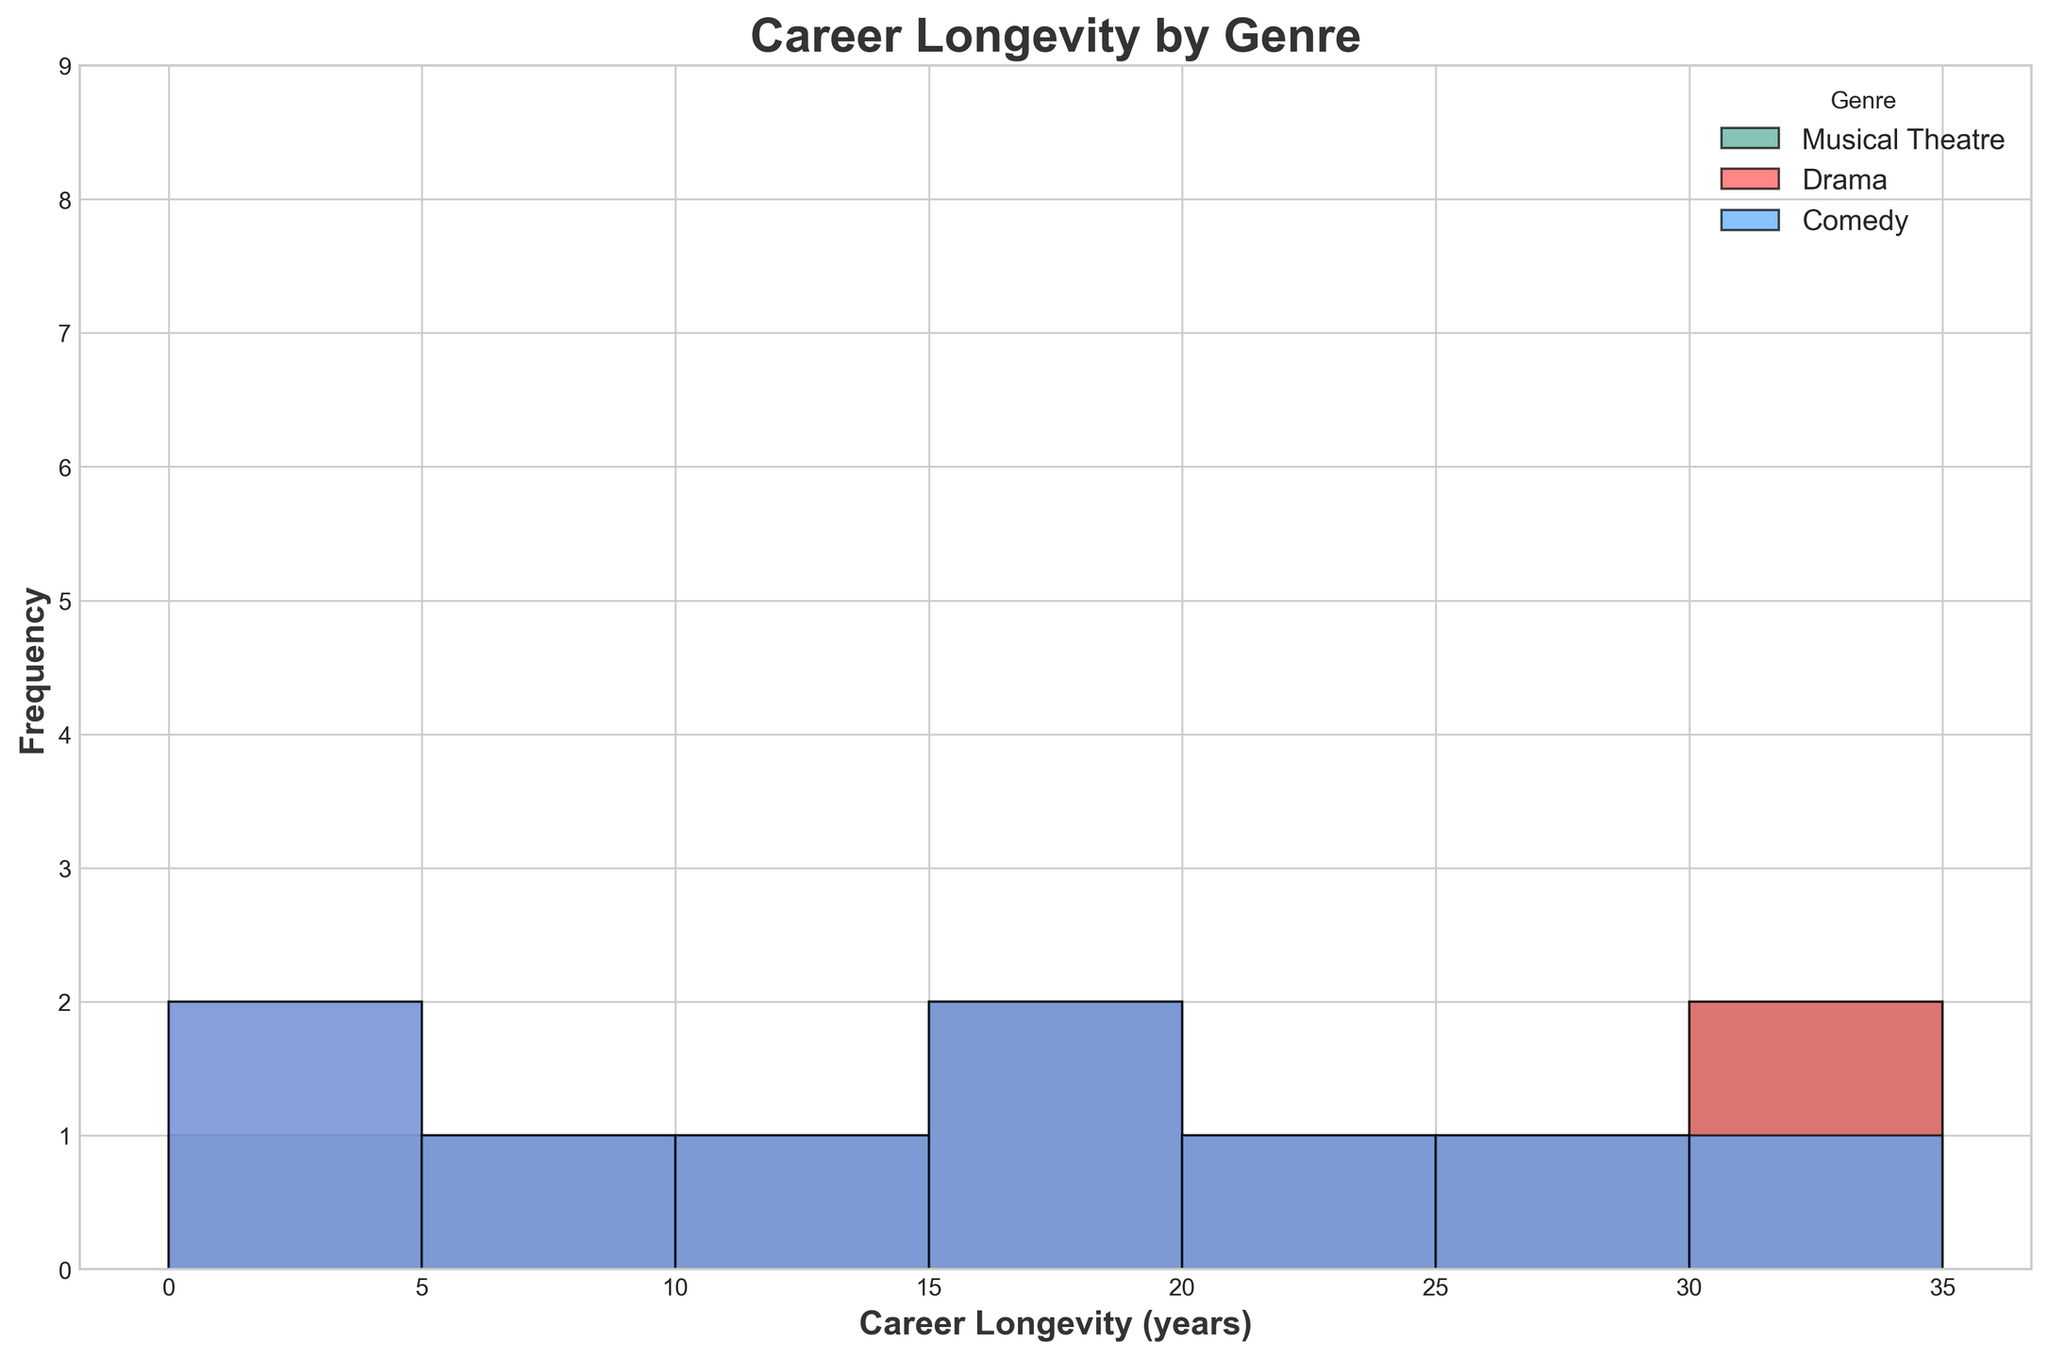What is the most common career longevity for actors in Comedy? By observing the height of the histogram bars, the tallest bar in the Comedy section corresponds to the 5-year career longevity mark, signifying its frequency is the highest.
Answer: 5 years How many different career longevity ranges are there for Drama? By counting the different bins in the Drama section of the histogram, we observe the career longevity ranges are 0-5, 5-10, 10-15, 15-20, 20-25, 25-30, and 30-35 years.
Answer: 7 Which genre has the highest number of actors with a career longevity of 25 years or more? Looking at the histogram bars for each genre, Drama has the tallest bars in the ranges 25-30 years and 30-35 years, indicating it has more actors in these categories compared to Musical Theatre and Comedy.
Answer: Drama In which genre is the career longevity of 35 years present? By checking the histogram, the 35-year career longevity bar appears in the Drama section but not in Musical Theatre or Comedy.
Answer: Drama What is the average career longevity for actors in Musical Theatre? For Musical Theatre, summing the career longevity values (5, 10, 15, 18, 20, 25, 30, 35) and dividing by the number of data points (8) we get (5+10+15+18+20+25+30+35) / 8 = 158 / 8 = 19.75.
Answer: 19.75 years Which genre features the most balanced distribution of actors' career longevity? Observing the histogram, it appears that Drama has a relatively balanced number of actors across different career longevity ranges, while Comedy and Musical Theatre show higher frequencies at certain points.
Answer: Drama Comparing Musical Theatre and Comedy, which genre has more actors with a career longevity less than 10 years? By checking the heights of the bars below 10 years in both genres, Comedy has taller bars in the <5 and 5-10 year ranges compared to Musical Theatre.
Answer: Comedy What is the combined frequency of actors with a career longevity less than 10 years across all genres? Adding the frequencies of the bars in the less than 10-year range for all genres, we have 2 (Musical Theatre) + 2+4 (Drama) + 5+4+1 (Comedy), so 2 + 6 + 10 = 18.
Answer: 18 